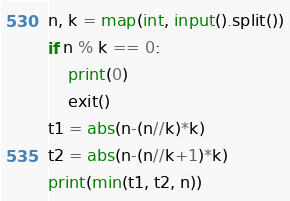Convert code to text. <code><loc_0><loc_0><loc_500><loc_500><_Python_>n, k = map(int, input().split())
if n % k == 0:
    print(0)
    exit()
t1 = abs(n-(n//k)*k)
t2 = abs(n-(n//k+1)*k)
print(min(t1, t2, n))
</code> 